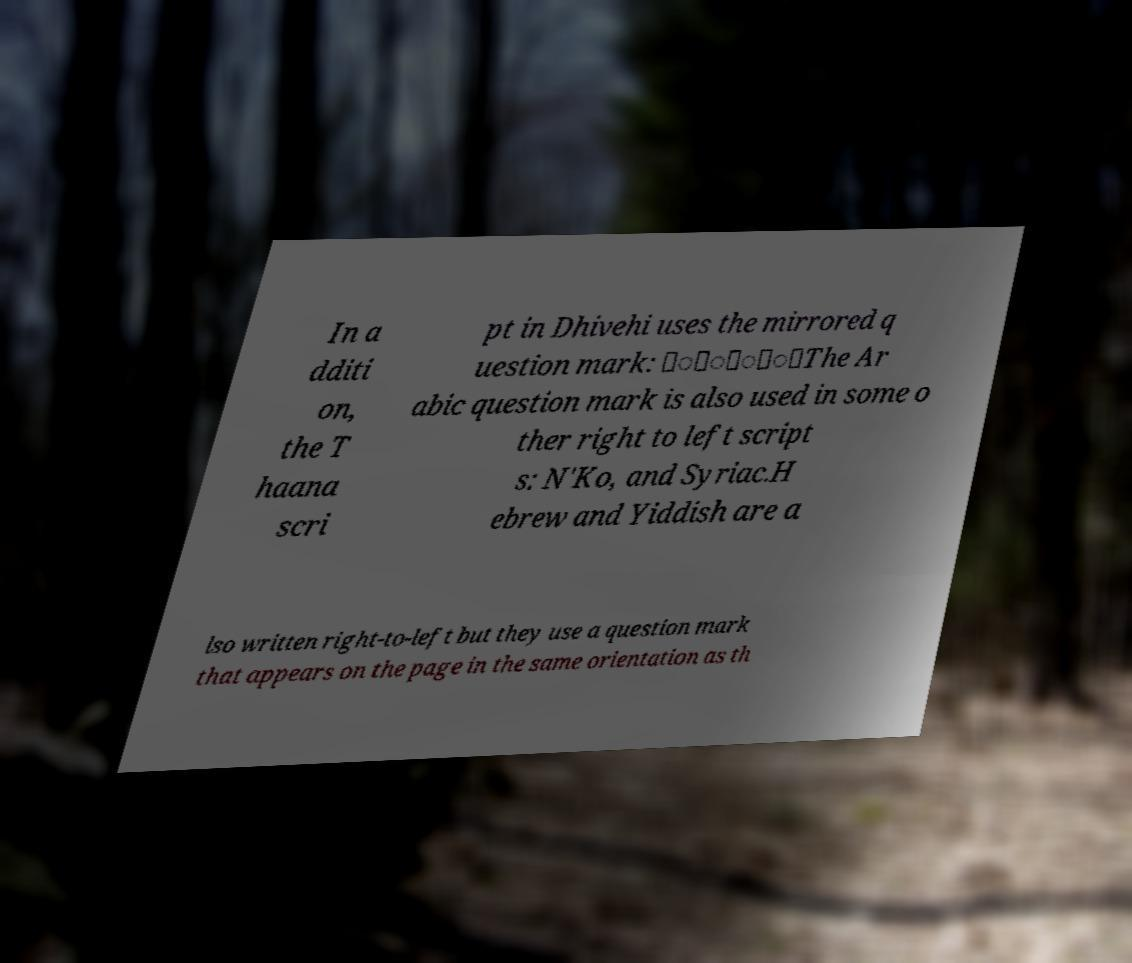There's text embedded in this image that I need extracted. Can you transcribe it verbatim? In a dditi on, the T haana scri pt in Dhivehi uses the mirrored q uestion mark: ަުަާ؟The Ar abic question mark is also used in some o ther right to left script s: N'Ko, and Syriac.H ebrew and Yiddish are a lso written right-to-left but they use a question mark that appears on the page in the same orientation as th 